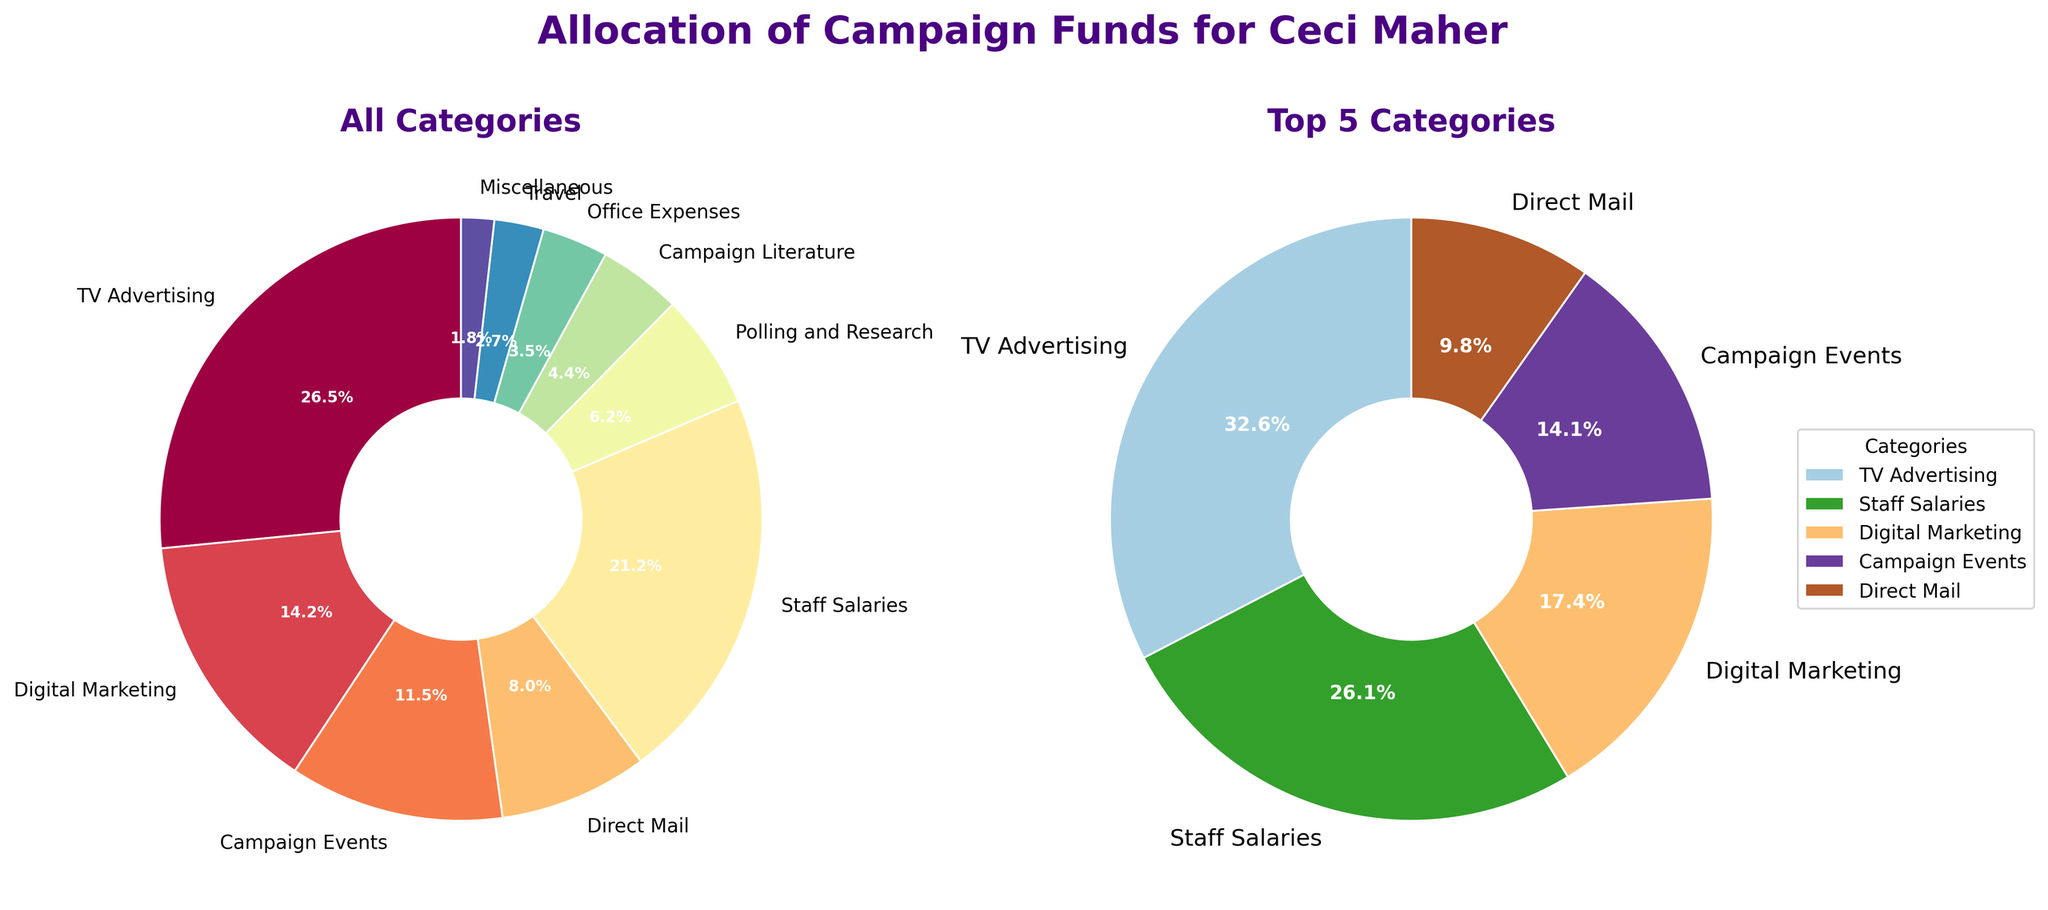What's the largest campaign fund category in the 'All Categories' pie chart? The 'All Categories' pie chart shows various categories of campaign funds, and by looking at the wedge sizes, you can find the largest one. The largest wedge corresponds to 'TV Advertising'.
Answer: TV Advertising Which categories are included in the 'Top 5 Categories' pie chart? The 'Top 5 Categories' pie chart displays the five largest funding categories by amount. These are indicated in the chart itself as 'TV Advertising', 'Staff Salaries', 'Digital Marketing', 'Campaign Events', and 'Direct Mail'.
Answer: TV Advertising, Staff Salaries, Digital Marketing, Campaign Events, Direct Mail What percentage of the total campaign funds is allocated to 'Polling and Research' in the 'All Categories' pie chart? In the 'All Categories' pie chart, each segment's percentage is labeled, and 'Polling and Research' is labeled with '6.3%', indicating its relative share of the total funds.
Answer: 6.3% How does the percentage allocated to 'Staff Salaries' compare to that for 'Digital Marketing' in the 'Top 5 Categories' pie chart? By examining the 'Top 5 Categories' pie chart, 'Staff Salaries' is shown to have a percentage of '30.6%' while 'Digital Marketing' has '20.4%'. Therefore, 'Staff Salaries' has a higher percentage.
Answer: Staff Salaries is higher What is the combined percentage of 'Campaign Events' and 'Direct Mail' in the 'Top 5 Categories' pie chart? In the 'Top 5 Categories' pie chart, 'Campaign Events' is '16.6%' and 'Direct Mail' is '11.5%'. Adding these together gives a combined percentage of 16.6 + 11.5 = 28.1%.
Answer: 28.1% Which category has the smallest allocation in the 'All Categories' pie chart? In the 'All Categories' pie chart, the segment representing 'Miscellaneous' is the smallest, which is labeled as having '1.8%' of the total campaign funds.
Answer: Miscellaneous What is the difference in percentage allocation between 'TV Advertising' and 'Staff Salaries' in the 'Top 5 Categories' pie chart? In the 'Top 5 Categories' pie chart, 'TV Advertising' is '38.3%' and 'Staff Salaries' is '30.6%'. Subtracting these percentages gives 38.3 - 30.6 = 7.7%.
Answer: 7.7% How many categories are displayed in the 'All Categories' pie chart? By counting the number of different segments in the 'All Categories' pie chart, one can see there are ten distinct categories displayed.
Answer: 10 Is the amount allocated to 'Travel' more or less than 'Office Expenses' in the 'All Categories' pie chart? By comparing the sizes of the respective wedges in the 'All Categories' pie chart, 'Travel' has a smaller segment compared to 'Office Expenses', indicating it has a smaller amount.
Answer: Less 